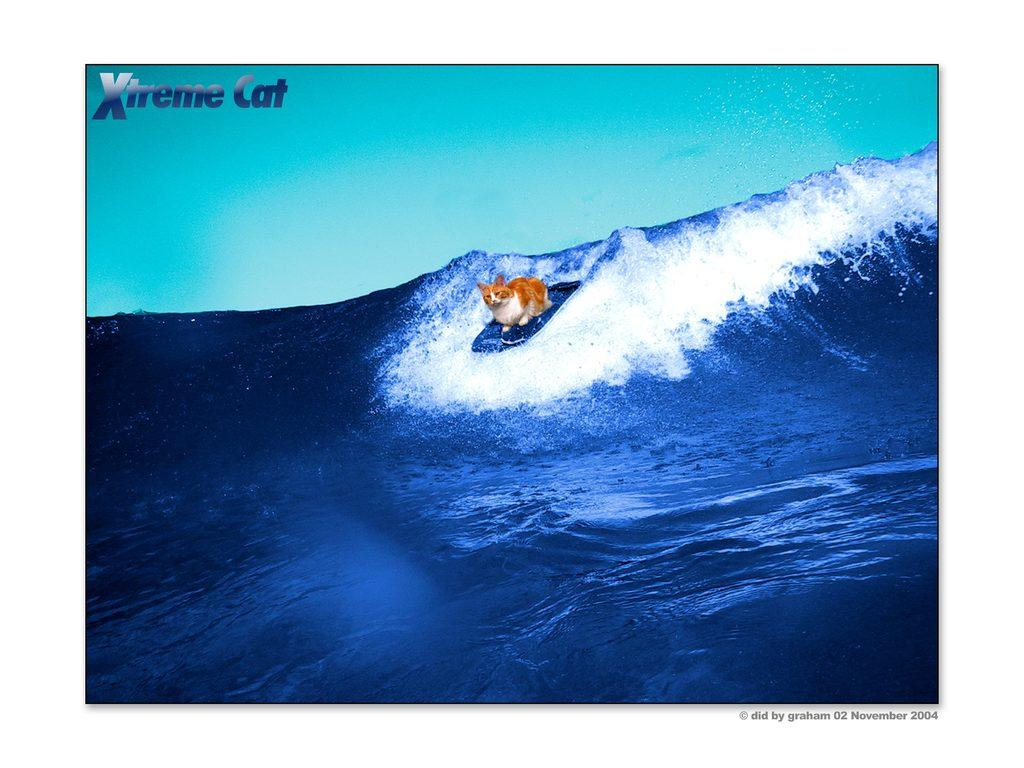What animal is present in the image? There is a cat in the image. What is the cat sitting on? The cat is sitting on a surfboard. Where is the cat located in the image? The cat is in the water. What type of ornament is hanging from the cat's neck in the image? There is no ornament hanging from the cat's neck in the image; the cat is simply sitting on a surfboard in the water. 